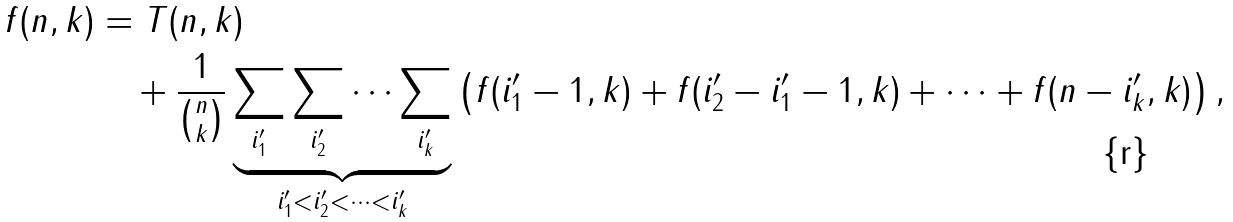Convert formula to latex. <formula><loc_0><loc_0><loc_500><loc_500>f ( n , k ) & = T ( n , k ) \\ & \quad + \frac { 1 } { \binom { n } { k } } \underbrace { \sum _ { i ^ { \prime } _ { 1 } } \sum _ { i ^ { \prime } _ { 2 } } \dots \sum _ { i ^ { \prime } _ { k } } } _ { i ^ { \prime } _ { 1 } < i ^ { \prime } _ { 2 } < \dots < i ^ { \prime } _ { k } } \left ( f ( i ^ { \prime } _ { 1 } - 1 , k ) + f ( i ^ { \prime } _ { 2 } - i ^ { \prime } _ { 1 } - 1 , k ) + \dots + f ( n - i ^ { \prime } _ { k } , k ) \right ) ,</formula> 